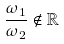<formula> <loc_0><loc_0><loc_500><loc_500>\frac { \omega _ { 1 } } { \omega _ { 2 } } \notin \mathbb { R }</formula> 